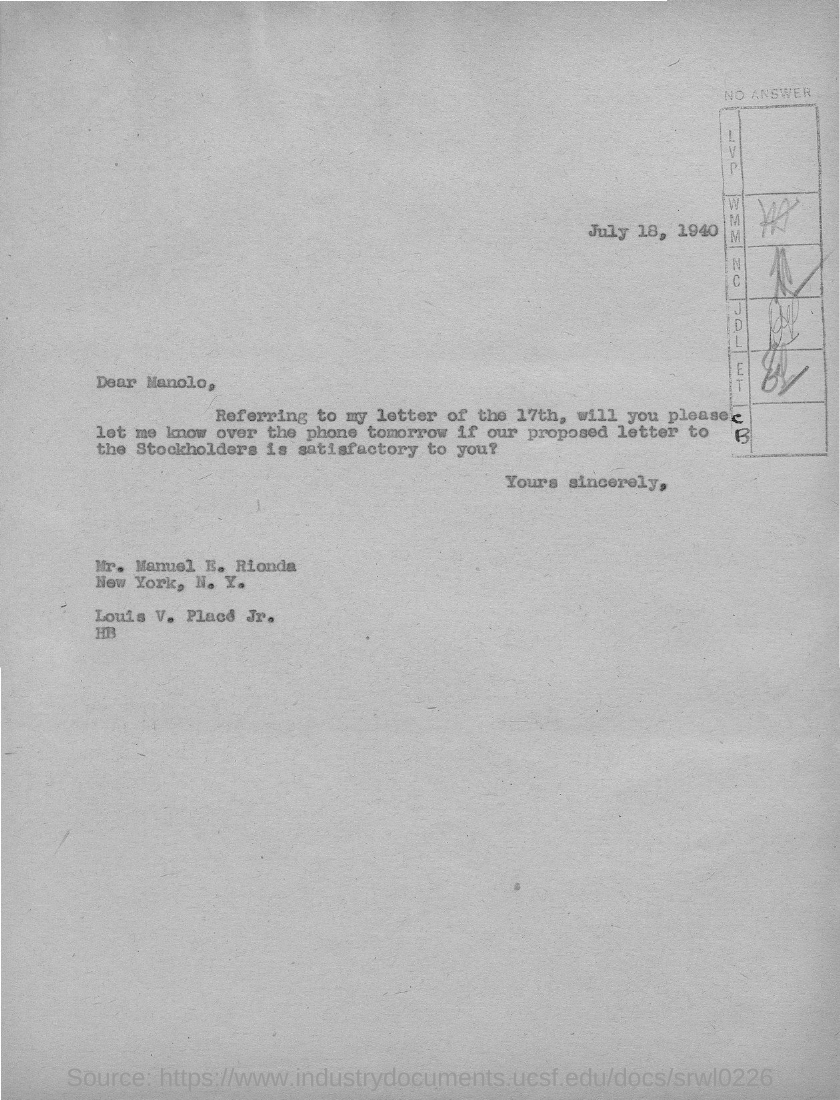Draw attention to some important aspects in this diagram. The letter is addressed to Manolo. The letter is dated July 18, 1940. 